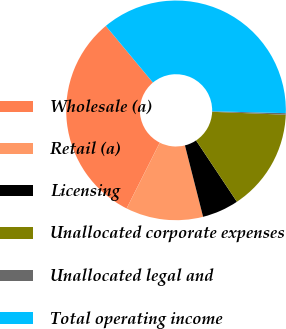<chart> <loc_0><loc_0><loc_500><loc_500><pie_chart><fcel>Wholesale (a)<fcel>Retail (a)<fcel>Licensing<fcel>Unallocated corporate expenses<fcel>Unallocated legal and<fcel>Total operating income<nl><fcel>31.53%<fcel>11.39%<fcel>5.39%<fcel>15.01%<fcel>0.23%<fcel>36.44%<nl></chart> 